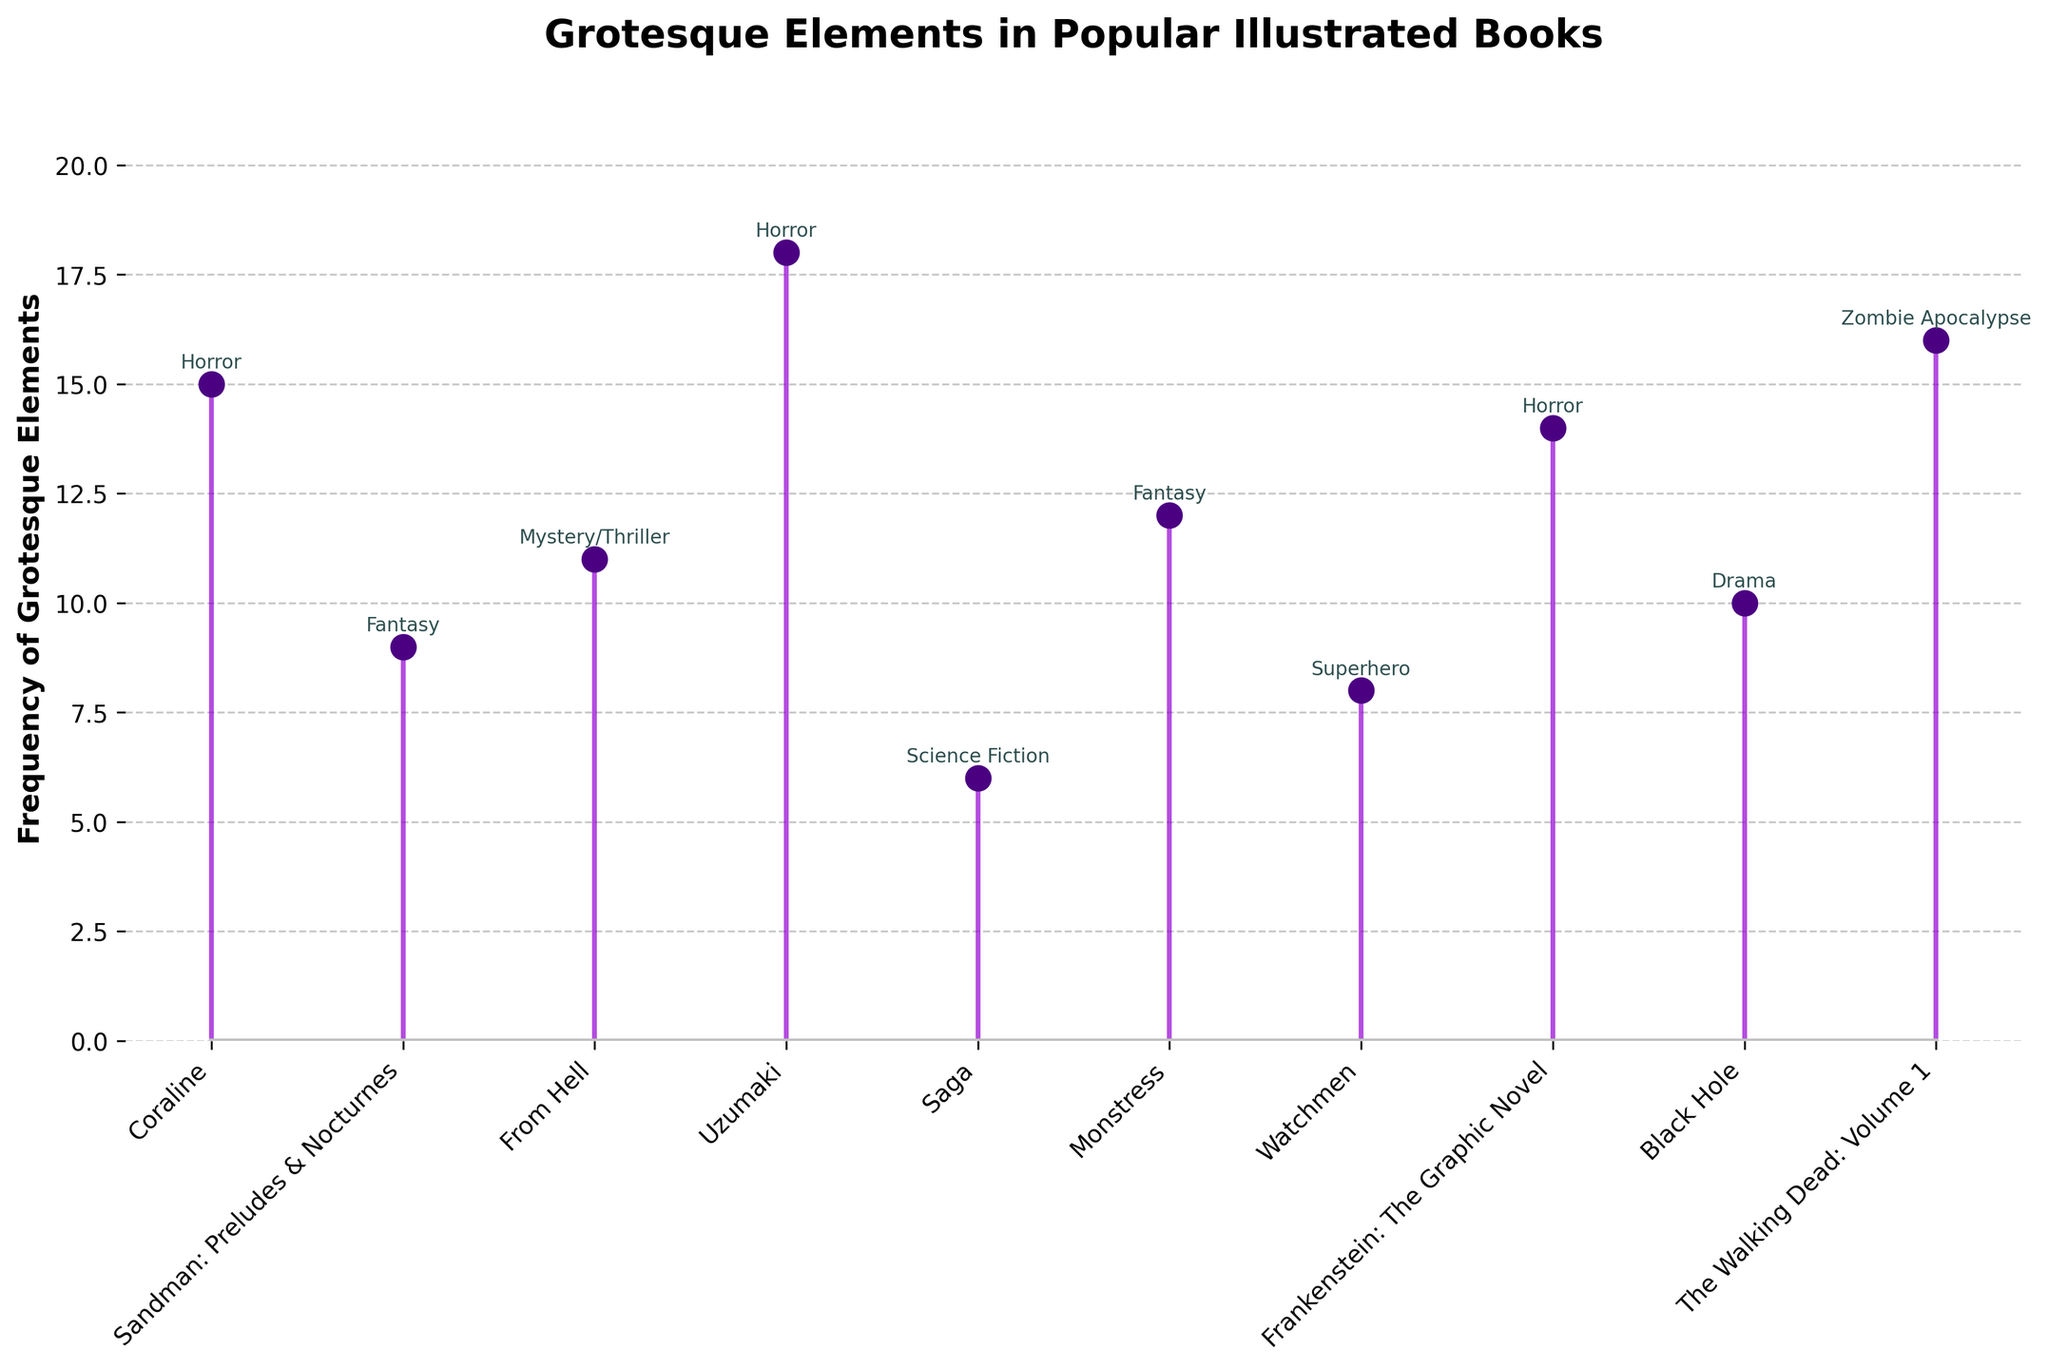what is the title of the plot? The title of the plot is displayed at the top center of the figure in bold. It is typically meant to provide a summary of the data being visualized.
Answer: Grotesque Elements in Popular Illustrated Books How many illustrated books are included in the plot? Count the number of stem points or markers present on the plot. Each point corresponds to a book title listed along the x-axis.
Answer: 10 Which genre has the highest frequency of grotesque elements? Look for the highest bar or point on the plot and refer to the corresponding genre annotation above this point.
Answer: Horror (Uzumaki) What is the frequency of grotesque elements in "Monstress"? Locate the position of "Monstress" on the x-axis, then find the corresponding y-value of the stem.
Answer: 12 Which book has the lowest frequency of grotesque elements, and what is the frequency? Identify the shortest stem on the plot and check the x-axis for the book title and the y-value for the frequency.
Answer: "Saga", 6 What is the median frequency of grotesque elements among the listed books? Organize the frequencies in ascending order and find the middle value. The list in ascending order is: 6, 8, 9, 10, 11, 12, 14, 15, 16, 18. Since there are 10 data points, the median is the average of the 5th and 6th values: (11 + 12) / 2.
Answer: 11.5 Which book with a Horror genre has the lowest frequency of grotesque elements? Identify the points corresponding to books in the "Horror" genre and find the one with the smallest y-value.
Answer: "Frankenstein: The Graphic Novel" (14) What is the average frequency of grotesque elements for illustrated books in the Horror genre? Summarize the frequencies of the books classified under Horror and divide by the total number of Horror books. Frequencies for Horror: 15 ("Coraline"), 18 ("Uzumaki"), and 14 ("Frankenstein: The Graphic Novel"). The sum is 15 + 18 + 14 = 47, and there are 3 books. 47 / 3.
Answer: 15.67 